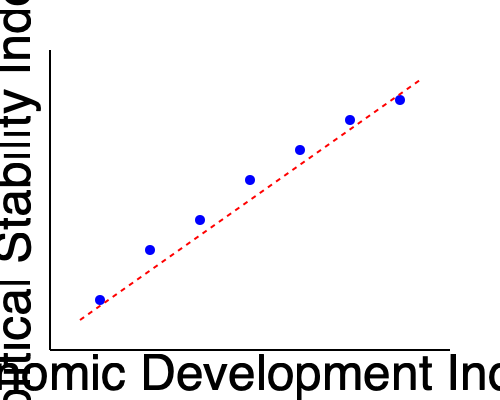Analyze the scatter plot depicting the relationship between economic development and political stability in post-conflict regions. What does the trend line suggest about the correlation between these two variables, and how might this inform policy recommendations for promoting stability in these areas? To answer this question, we need to analyze the scatter plot and its implications step-by-step:

1. Scatter plot interpretation:
   - The x-axis represents the Economic Development Index
   - The y-axis represents the Political Stability Index
   - Each blue dot represents a data point for a post-conflict region

2. Trend line analysis:
   - The red dashed line represents the trend line
   - The trend line has a negative slope, moving from the upper left to the lower right

3. Correlation interpretation:
   - The negative slope of the trend line indicates a positive correlation between economic development and political stability
   - As the Economic Development Index increases, the Political Stability Index also tends to increase (note that a lower value on the y-axis indicates higher stability)

4. Strength of correlation:
   - The data points are relatively close to the trend line, suggesting a moderately strong correlation
   - There is some scatter around the line, indicating that other factors may also influence political stability

5. Implications for post-conflict regions:
   - The data suggests that improving economic development may lead to increased political stability
   - However, the relationship is not perfect, implying that economic development alone may not guarantee political stability

6. Policy recommendations:
   - Focus on economic development initiatives to promote political stability
   - Implement programs that foster economic growth, such as infrastructure development, job creation, and foreign investment
   - Combine economic policies with other stability-promoting measures, such as institutional reforms and security sector improvements
   - Tailor policies to the specific context of each post-conflict region, as the relationship may vary in strength or nature across different cases

7. Limitations and considerations:
   - Correlation does not imply causation; other factors may influence both variables
   - The timeframe and specific measures used for each index should be considered
   - Regional variations and outliers should be examined for a more comprehensive analysis
Answer: The trend line suggests a positive correlation between economic development and political stability in post-conflict regions, implying that policies promoting economic growth may contribute to increased stability, although other factors should also be considered in comprehensive policy recommendations. 